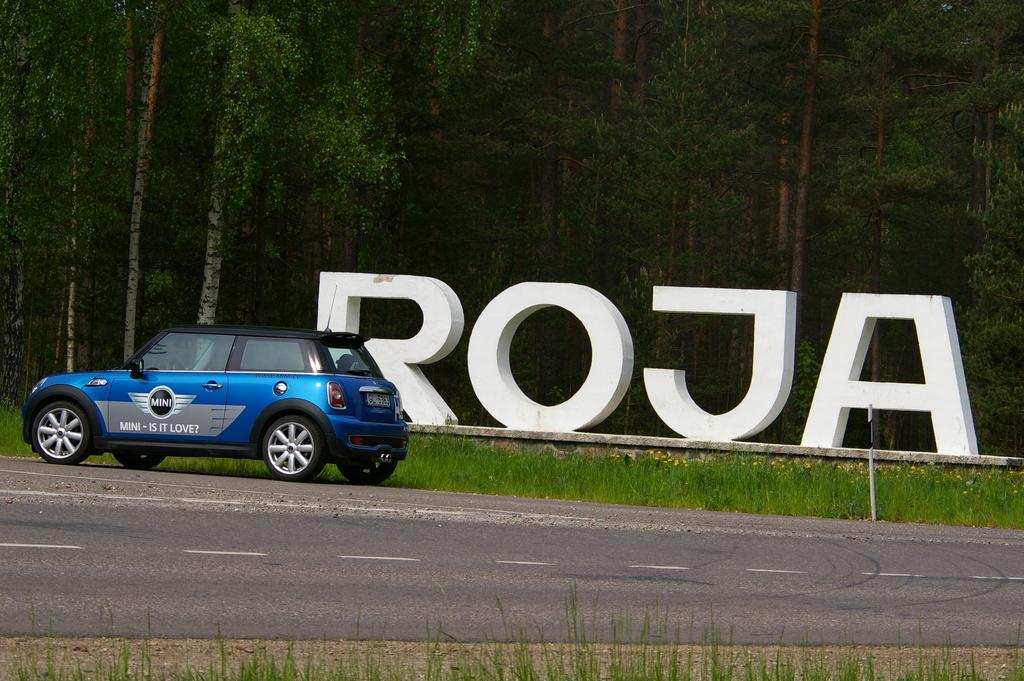What is on the road in the image? There is a car on the road in the image. What can be seen on the wall in the image? There are letters on a wall in the image. What type of vegetation is visible in the image? There is grass visible in the image. What do the trees in the image have? The trees in the image have branches and leaves. What type of food is being served under the tree in the image? There is no food or tree present in the image; it only shows a car on the road, letters on a wall, grass, and trees with branches and leaves. How many people are using the shade provided by the tree in the image? There is no tree or people present in the image. 